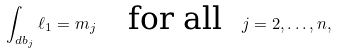<formula> <loc_0><loc_0><loc_500><loc_500>\int _ { d b _ { j } } \ell _ { 1 } = m _ { j } \quad \text {for all} \ \ j = 2 , \dots , n ,</formula> 